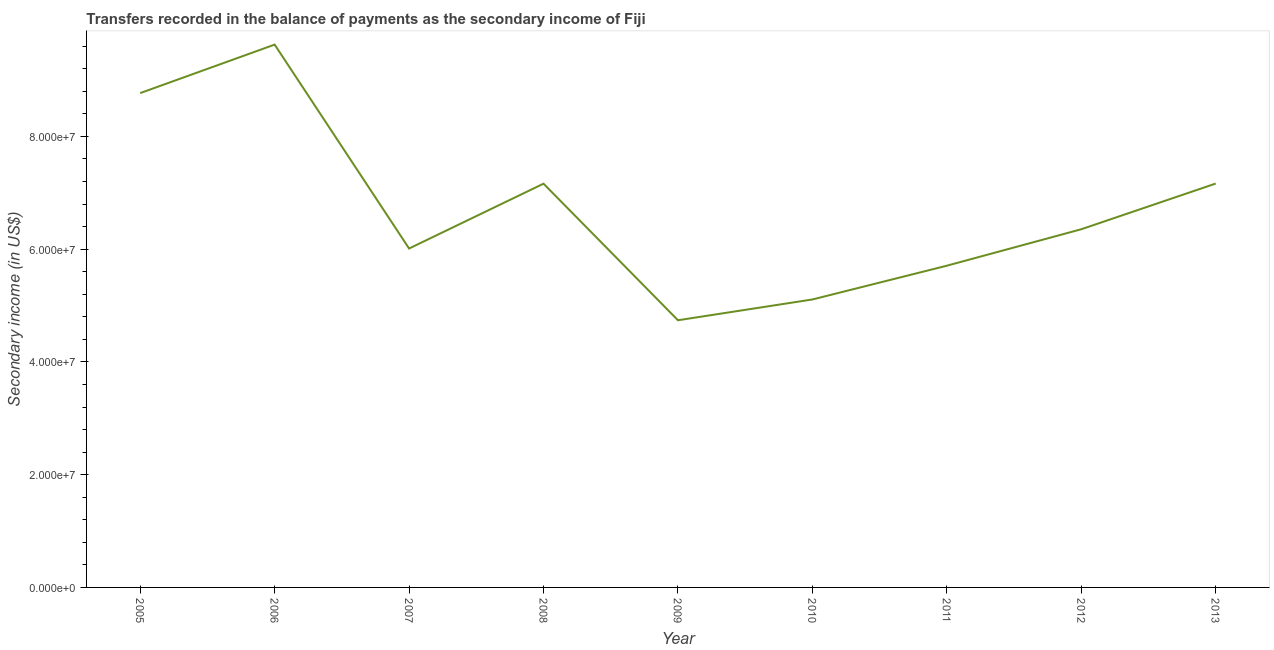What is the amount of secondary income in 2010?
Keep it short and to the point. 5.11e+07. Across all years, what is the maximum amount of secondary income?
Your answer should be compact. 9.63e+07. Across all years, what is the minimum amount of secondary income?
Offer a terse response. 4.74e+07. What is the sum of the amount of secondary income?
Give a very brief answer. 6.06e+08. What is the difference between the amount of secondary income in 2005 and 2009?
Ensure brevity in your answer.  4.03e+07. What is the average amount of secondary income per year?
Make the answer very short. 6.74e+07. What is the median amount of secondary income?
Your answer should be very brief. 6.35e+07. In how many years, is the amount of secondary income greater than 48000000 US$?
Give a very brief answer. 8. Do a majority of the years between 2009 and 2006 (inclusive) have amount of secondary income greater than 24000000 US$?
Make the answer very short. Yes. What is the ratio of the amount of secondary income in 2010 to that in 2011?
Offer a terse response. 0.9. Is the difference between the amount of secondary income in 2008 and 2011 greater than the difference between any two years?
Provide a short and direct response. No. What is the difference between the highest and the second highest amount of secondary income?
Provide a succinct answer. 8.60e+06. What is the difference between the highest and the lowest amount of secondary income?
Make the answer very short. 4.89e+07. In how many years, is the amount of secondary income greater than the average amount of secondary income taken over all years?
Your answer should be very brief. 4. Does the amount of secondary income monotonically increase over the years?
Provide a short and direct response. No. How many lines are there?
Offer a terse response. 1. How many years are there in the graph?
Your answer should be very brief. 9. Does the graph contain any zero values?
Offer a terse response. No. Does the graph contain grids?
Your response must be concise. No. What is the title of the graph?
Ensure brevity in your answer.  Transfers recorded in the balance of payments as the secondary income of Fiji. What is the label or title of the Y-axis?
Provide a short and direct response. Secondary income (in US$). What is the Secondary income (in US$) of 2005?
Make the answer very short. 8.77e+07. What is the Secondary income (in US$) of 2006?
Your response must be concise. 9.63e+07. What is the Secondary income (in US$) of 2007?
Ensure brevity in your answer.  6.01e+07. What is the Secondary income (in US$) in 2008?
Offer a very short reply. 7.16e+07. What is the Secondary income (in US$) in 2009?
Your answer should be very brief. 4.74e+07. What is the Secondary income (in US$) in 2010?
Offer a terse response. 5.11e+07. What is the Secondary income (in US$) of 2011?
Your answer should be compact. 5.71e+07. What is the Secondary income (in US$) of 2012?
Give a very brief answer. 6.35e+07. What is the Secondary income (in US$) of 2013?
Your response must be concise. 7.16e+07. What is the difference between the Secondary income (in US$) in 2005 and 2006?
Provide a succinct answer. -8.60e+06. What is the difference between the Secondary income (in US$) in 2005 and 2007?
Provide a short and direct response. 2.76e+07. What is the difference between the Secondary income (in US$) in 2005 and 2008?
Your answer should be very brief. 1.61e+07. What is the difference between the Secondary income (in US$) in 2005 and 2009?
Your response must be concise. 4.03e+07. What is the difference between the Secondary income (in US$) in 2005 and 2010?
Your answer should be compact. 3.66e+07. What is the difference between the Secondary income (in US$) in 2005 and 2011?
Your response must be concise. 3.06e+07. What is the difference between the Secondary income (in US$) in 2005 and 2012?
Give a very brief answer. 2.42e+07. What is the difference between the Secondary income (in US$) in 2005 and 2013?
Keep it short and to the point. 1.60e+07. What is the difference between the Secondary income (in US$) in 2006 and 2007?
Give a very brief answer. 3.62e+07. What is the difference between the Secondary income (in US$) in 2006 and 2008?
Provide a succinct answer. 2.47e+07. What is the difference between the Secondary income (in US$) in 2006 and 2009?
Give a very brief answer. 4.89e+07. What is the difference between the Secondary income (in US$) in 2006 and 2010?
Provide a short and direct response. 4.52e+07. What is the difference between the Secondary income (in US$) in 2006 and 2011?
Keep it short and to the point. 3.92e+07. What is the difference between the Secondary income (in US$) in 2006 and 2012?
Offer a very short reply. 3.28e+07. What is the difference between the Secondary income (in US$) in 2006 and 2013?
Your answer should be compact. 2.46e+07. What is the difference between the Secondary income (in US$) in 2007 and 2008?
Your response must be concise. -1.15e+07. What is the difference between the Secondary income (in US$) in 2007 and 2009?
Provide a succinct answer. 1.27e+07. What is the difference between the Secondary income (in US$) in 2007 and 2010?
Make the answer very short. 9.04e+06. What is the difference between the Secondary income (in US$) in 2007 and 2011?
Keep it short and to the point. 3.05e+06. What is the difference between the Secondary income (in US$) in 2007 and 2012?
Provide a short and direct response. -3.42e+06. What is the difference between the Secondary income (in US$) in 2007 and 2013?
Provide a succinct answer. -1.15e+07. What is the difference between the Secondary income (in US$) in 2008 and 2009?
Give a very brief answer. 2.42e+07. What is the difference between the Secondary income (in US$) in 2008 and 2010?
Provide a short and direct response. 2.05e+07. What is the difference between the Secondary income (in US$) in 2008 and 2011?
Your response must be concise. 1.45e+07. What is the difference between the Secondary income (in US$) in 2008 and 2012?
Offer a very short reply. 8.08e+06. What is the difference between the Secondary income (in US$) in 2008 and 2013?
Provide a succinct answer. -2.35e+04. What is the difference between the Secondary income (in US$) in 2009 and 2010?
Your answer should be very brief. -3.69e+06. What is the difference between the Secondary income (in US$) in 2009 and 2011?
Your answer should be very brief. -9.68e+06. What is the difference between the Secondary income (in US$) in 2009 and 2012?
Keep it short and to the point. -1.61e+07. What is the difference between the Secondary income (in US$) in 2009 and 2013?
Your answer should be very brief. -2.42e+07. What is the difference between the Secondary income (in US$) in 2010 and 2011?
Ensure brevity in your answer.  -5.99e+06. What is the difference between the Secondary income (in US$) in 2010 and 2012?
Provide a short and direct response. -1.25e+07. What is the difference between the Secondary income (in US$) in 2010 and 2013?
Offer a terse response. -2.06e+07. What is the difference between the Secondary income (in US$) in 2011 and 2012?
Ensure brevity in your answer.  -6.46e+06. What is the difference between the Secondary income (in US$) in 2011 and 2013?
Your answer should be very brief. -1.46e+07. What is the difference between the Secondary income (in US$) in 2012 and 2013?
Your response must be concise. -8.11e+06. What is the ratio of the Secondary income (in US$) in 2005 to that in 2006?
Provide a short and direct response. 0.91. What is the ratio of the Secondary income (in US$) in 2005 to that in 2007?
Offer a very short reply. 1.46. What is the ratio of the Secondary income (in US$) in 2005 to that in 2008?
Give a very brief answer. 1.22. What is the ratio of the Secondary income (in US$) in 2005 to that in 2009?
Provide a succinct answer. 1.85. What is the ratio of the Secondary income (in US$) in 2005 to that in 2010?
Your response must be concise. 1.72. What is the ratio of the Secondary income (in US$) in 2005 to that in 2011?
Provide a succinct answer. 1.54. What is the ratio of the Secondary income (in US$) in 2005 to that in 2012?
Your answer should be very brief. 1.38. What is the ratio of the Secondary income (in US$) in 2005 to that in 2013?
Make the answer very short. 1.22. What is the ratio of the Secondary income (in US$) in 2006 to that in 2007?
Ensure brevity in your answer.  1.6. What is the ratio of the Secondary income (in US$) in 2006 to that in 2008?
Ensure brevity in your answer.  1.34. What is the ratio of the Secondary income (in US$) in 2006 to that in 2009?
Offer a very short reply. 2.03. What is the ratio of the Secondary income (in US$) in 2006 to that in 2010?
Your response must be concise. 1.89. What is the ratio of the Secondary income (in US$) in 2006 to that in 2011?
Keep it short and to the point. 1.69. What is the ratio of the Secondary income (in US$) in 2006 to that in 2012?
Ensure brevity in your answer.  1.52. What is the ratio of the Secondary income (in US$) in 2006 to that in 2013?
Offer a terse response. 1.34. What is the ratio of the Secondary income (in US$) in 2007 to that in 2008?
Offer a terse response. 0.84. What is the ratio of the Secondary income (in US$) in 2007 to that in 2009?
Offer a very short reply. 1.27. What is the ratio of the Secondary income (in US$) in 2007 to that in 2010?
Offer a terse response. 1.18. What is the ratio of the Secondary income (in US$) in 2007 to that in 2011?
Give a very brief answer. 1.05. What is the ratio of the Secondary income (in US$) in 2007 to that in 2012?
Provide a succinct answer. 0.95. What is the ratio of the Secondary income (in US$) in 2007 to that in 2013?
Make the answer very short. 0.84. What is the ratio of the Secondary income (in US$) in 2008 to that in 2009?
Offer a very short reply. 1.51. What is the ratio of the Secondary income (in US$) in 2008 to that in 2010?
Your response must be concise. 1.4. What is the ratio of the Secondary income (in US$) in 2008 to that in 2011?
Offer a terse response. 1.25. What is the ratio of the Secondary income (in US$) in 2008 to that in 2012?
Offer a very short reply. 1.13. What is the ratio of the Secondary income (in US$) in 2008 to that in 2013?
Provide a short and direct response. 1. What is the ratio of the Secondary income (in US$) in 2009 to that in 2010?
Offer a very short reply. 0.93. What is the ratio of the Secondary income (in US$) in 2009 to that in 2011?
Your response must be concise. 0.83. What is the ratio of the Secondary income (in US$) in 2009 to that in 2012?
Offer a very short reply. 0.75. What is the ratio of the Secondary income (in US$) in 2009 to that in 2013?
Your answer should be compact. 0.66. What is the ratio of the Secondary income (in US$) in 2010 to that in 2011?
Your answer should be compact. 0.9. What is the ratio of the Secondary income (in US$) in 2010 to that in 2012?
Your response must be concise. 0.8. What is the ratio of the Secondary income (in US$) in 2010 to that in 2013?
Keep it short and to the point. 0.71. What is the ratio of the Secondary income (in US$) in 2011 to that in 2012?
Ensure brevity in your answer.  0.9. What is the ratio of the Secondary income (in US$) in 2011 to that in 2013?
Your answer should be very brief. 0.8. What is the ratio of the Secondary income (in US$) in 2012 to that in 2013?
Offer a terse response. 0.89. 